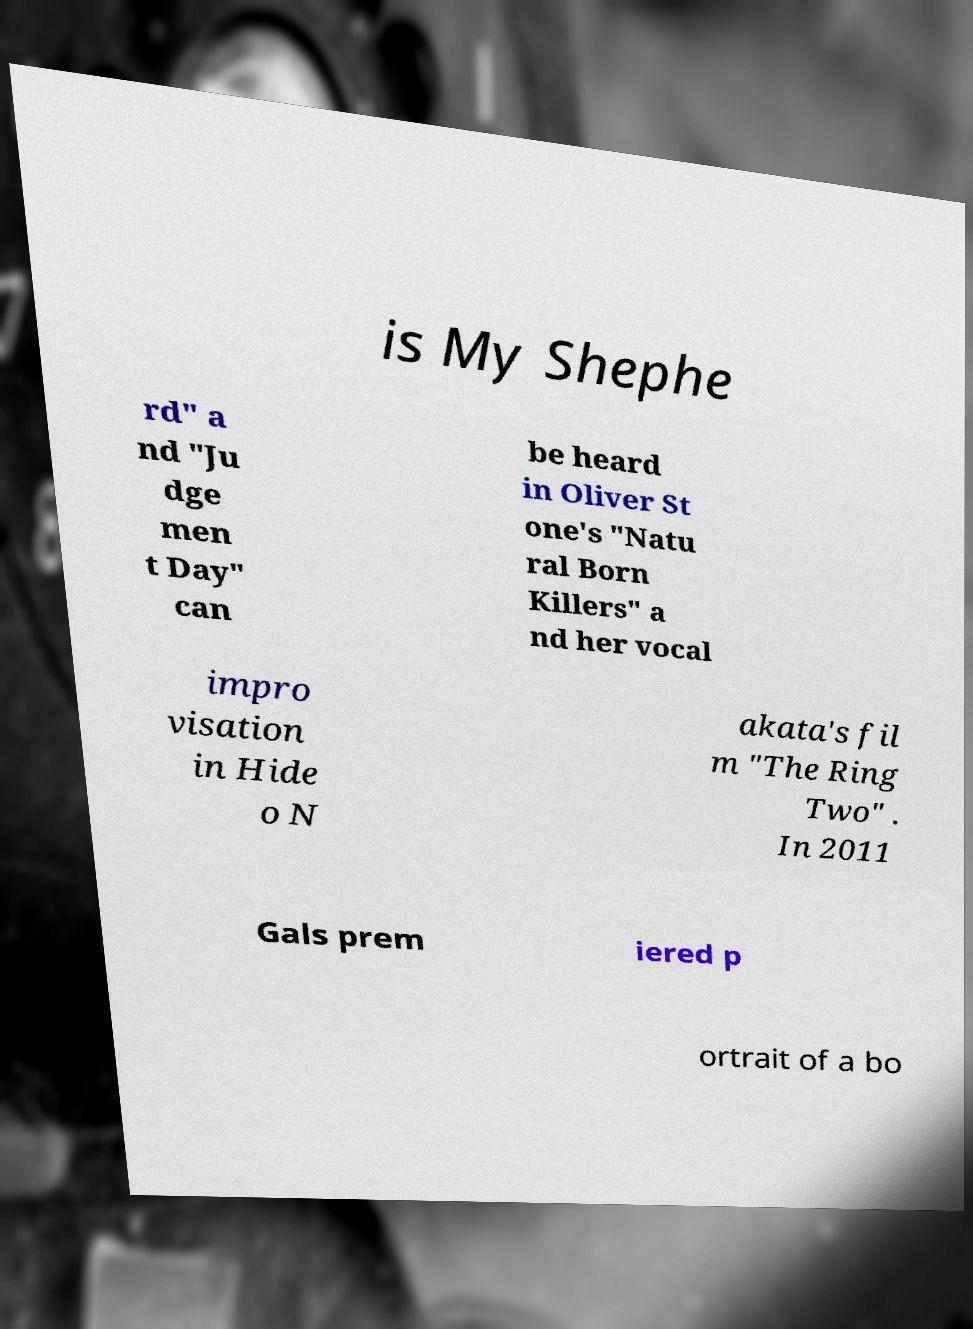Can you accurately transcribe the text from the provided image for me? is My Shephe rd" a nd "Ju dge men t Day" can be heard in Oliver St one's "Natu ral Born Killers" a nd her vocal impro visation in Hide o N akata's fil m "The Ring Two" . In 2011 Gals prem iered p ortrait of a bo 